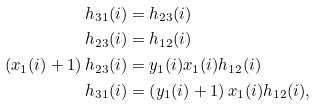Convert formula to latex. <formula><loc_0><loc_0><loc_500><loc_500>h _ { 3 1 } ( i ) & = h _ { 2 3 } ( i ) \\ h _ { 2 3 } ( i ) & = h _ { 1 2 } ( i ) \\ \left ( x _ { 1 } ( i ) + 1 \right ) h _ { 2 3 } ( i ) & = y _ { 1 } ( i ) x _ { 1 } ( i ) h _ { 1 2 } ( i ) \\ h _ { 3 1 } ( i ) & = \left ( y _ { 1 } ( i ) + 1 \right ) x _ { 1 } ( i ) h _ { 1 2 } ( i ) ,</formula> 